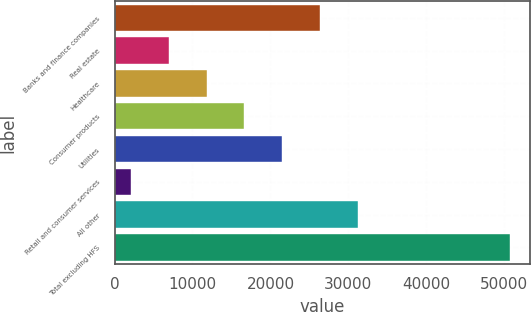Convert chart to OTSL. <chart><loc_0><loc_0><loc_500><loc_500><bar_chart><fcel>Banks and finance companies<fcel>Real estate<fcel>Healthcare<fcel>Consumer products<fcel>Utilities<fcel>Retail and consumer services<fcel>All other<fcel>Total excluding HFS<nl><fcel>26401<fcel>6935.4<fcel>11801.8<fcel>16668.2<fcel>21534.6<fcel>2069<fcel>31267.4<fcel>50733<nl></chart> 